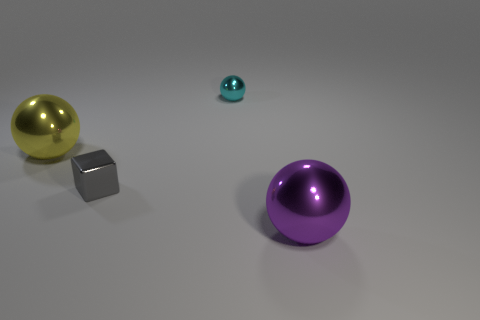Do the large thing that is behind the large purple object and the purple thing have the same material?
Give a very brief answer. Yes. Is the number of large purple balls that are on the right side of the large purple shiny ball less than the number of large gray shiny cubes?
Ensure brevity in your answer.  No. There is a big metal object in front of the yellow shiny sphere; what shape is it?
Your response must be concise. Sphere. There is a cyan thing that is the same size as the gray object; what shape is it?
Provide a succinct answer. Sphere. Is there a blue metal object of the same shape as the yellow thing?
Offer a terse response. No. There is a large thing right of the yellow object; is its shape the same as the tiny object on the right side of the gray metallic thing?
Keep it short and to the point. Yes. What shape is the big shiny object on the left side of the ball that is on the right side of the tiny cyan sphere?
Your answer should be compact. Sphere. What number of objects are large purple metal spheres or large metallic objects that are to the right of the small sphere?
Ensure brevity in your answer.  1. How many other objects are there of the same color as the tiny metallic ball?
Provide a succinct answer. 0. How many yellow objects are balls or small objects?
Give a very brief answer. 1. 